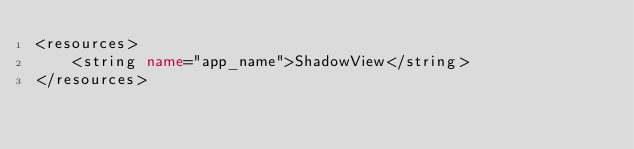Convert code to text. <code><loc_0><loc_0><loc_500><loc_500><_XML_><resources>
    <string name="app_name">ShadowView</string>
</resources></code> 